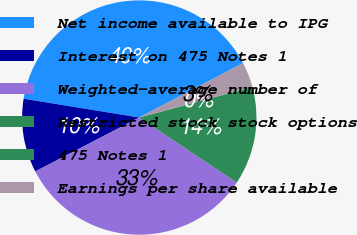<chart> <loc_0><loc_0><loc_500><loc_500><pie_chart><fcel>Net income available to IPG<fcel>Interest on 475 Notes 1<fcel>Weighted-average number of<fcel>Restricted stock stock options<fcel>475 Notes 1<fcel>Earnings per share available<nl><fcel>39.75%<fcel>10.18%<fcel>33.02%<fcel>13.54%<fcel>0.08%<fcel>3.44%<nl></chart> 